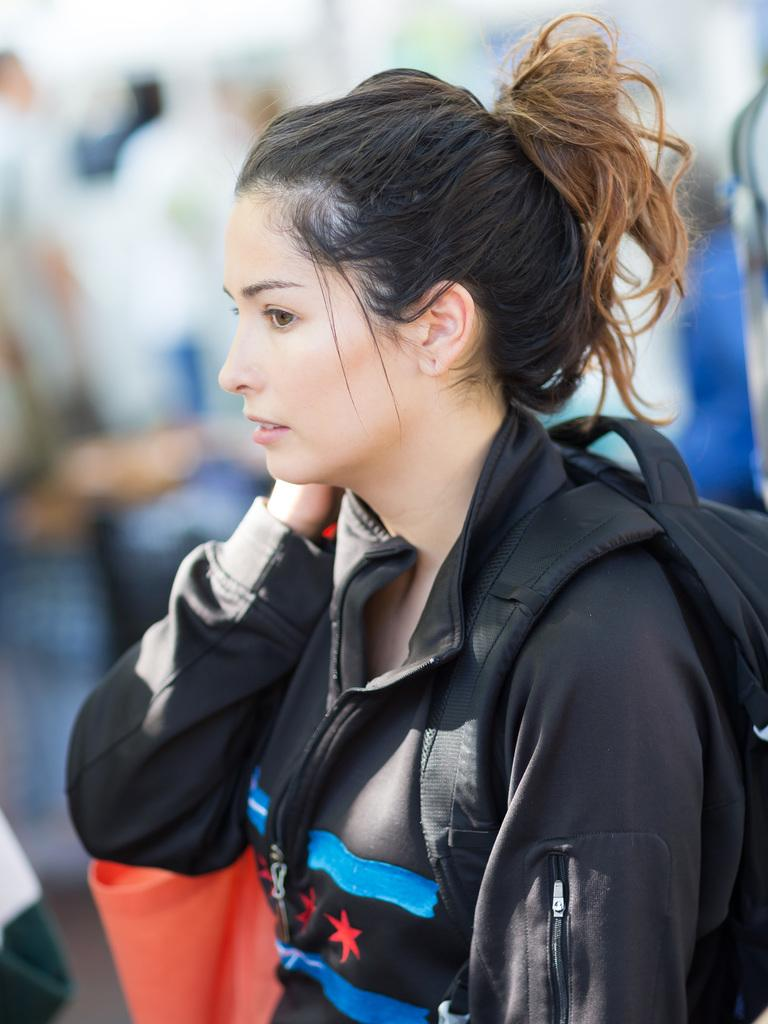Who or what is the main subject in the image? There is a person in the image. What is the person wearing in the image? The person is wearing a bag. Can you describe the surrounding environment in the image? There are other people behind the person in the image. What type of bell can be heard ringing in the image? There is no bell present or ringing in the image. Is there a trail visible in the image? The provided facts do not mention a trail, so it cannot be determined if one is visible in the image. 